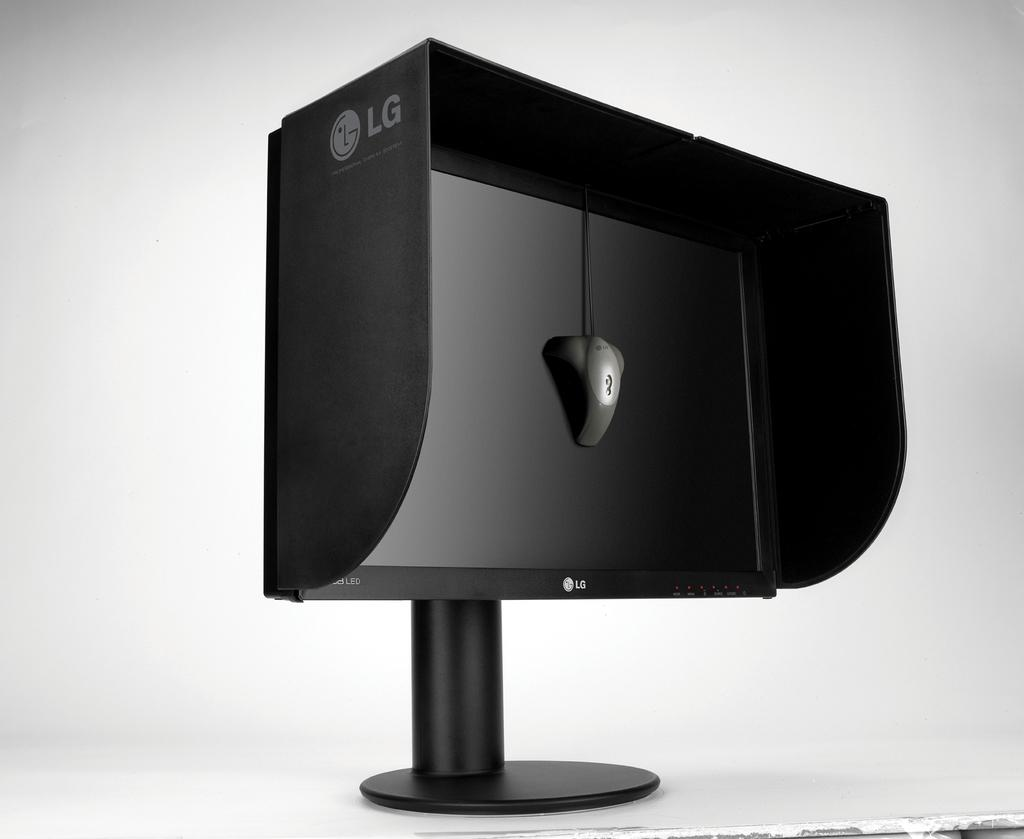Provide a one-sentence caption for the provided image. An LG branded black monitor with the side covers included on it. 